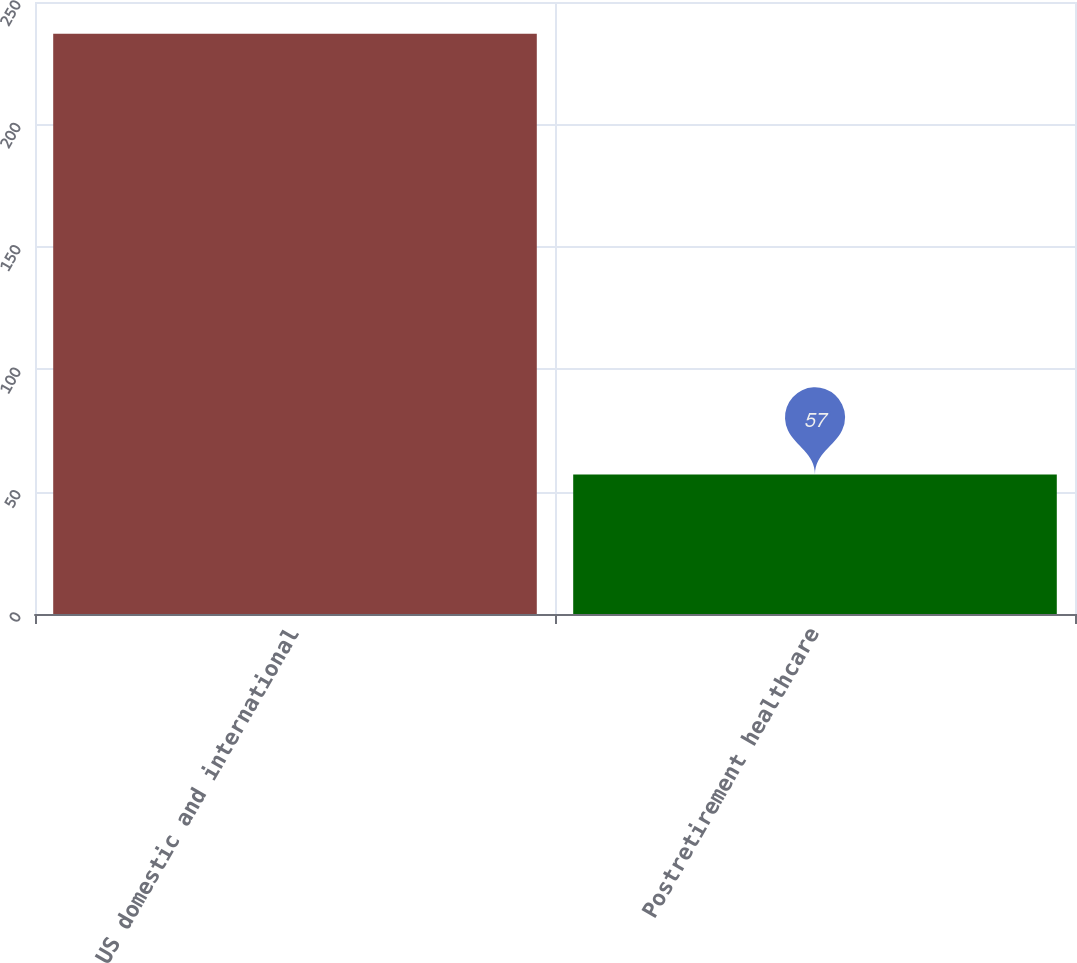<chart> <loc_0><loc_0><loc_500><loc_500><bar_chart><fcel>US domestic and international<fcel>Postretirement healthcare<nl><fcel>237<fcel>57<nl></chart> 